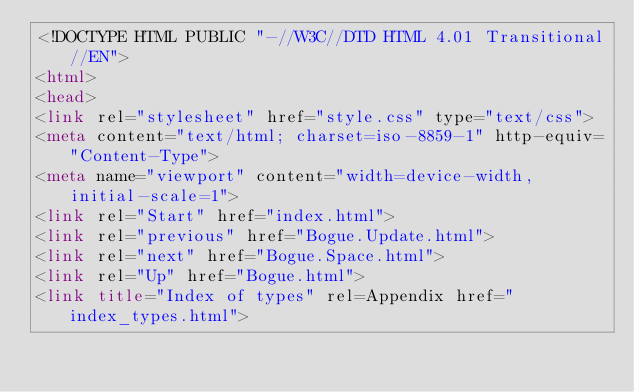<code> <loc_0><loc_0><loc_500><loc_500><_HTML_><!DOCTYPE HTML PUBLIC "-//W3C//DTD HTML 4.01 Transitional//EN">
<html>
<head>
<link rel="stylesheet" href="style.css" type="text/css">
<meta content="text/html; charset=iso-8859-1" http-equiv="Content-Type">
<meta name="viewport" content="width=device-width, initial-scale=1">
<link rel="Start" href="index.html">
<link rel="previous" href="Bogue.Update.html">
<link rel="next" href="Bogue.Space.html">
<link rel="Up" href="Bogue.html">
<link title="Index of types" rel=Appendix href="index_types.html"></code> 